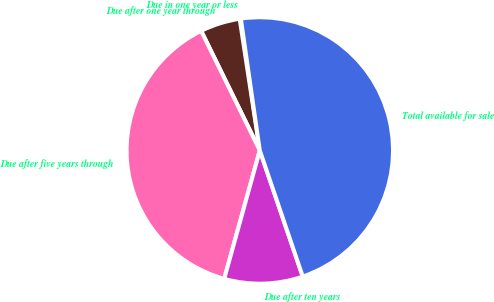<chart> <loc_0><loc_0><loc_500><loc_500><pie_chart><fcel>Due in one year or less<fcel>Due after one year through<fcel>Due after five years through<fcel>Due after ten years<fcel>Total available for sale<nl><fcel>0.14%<fcel>4.84%<fcel>38.44%<fcel>9.53%<fcel>47.05%<nl></chart> 